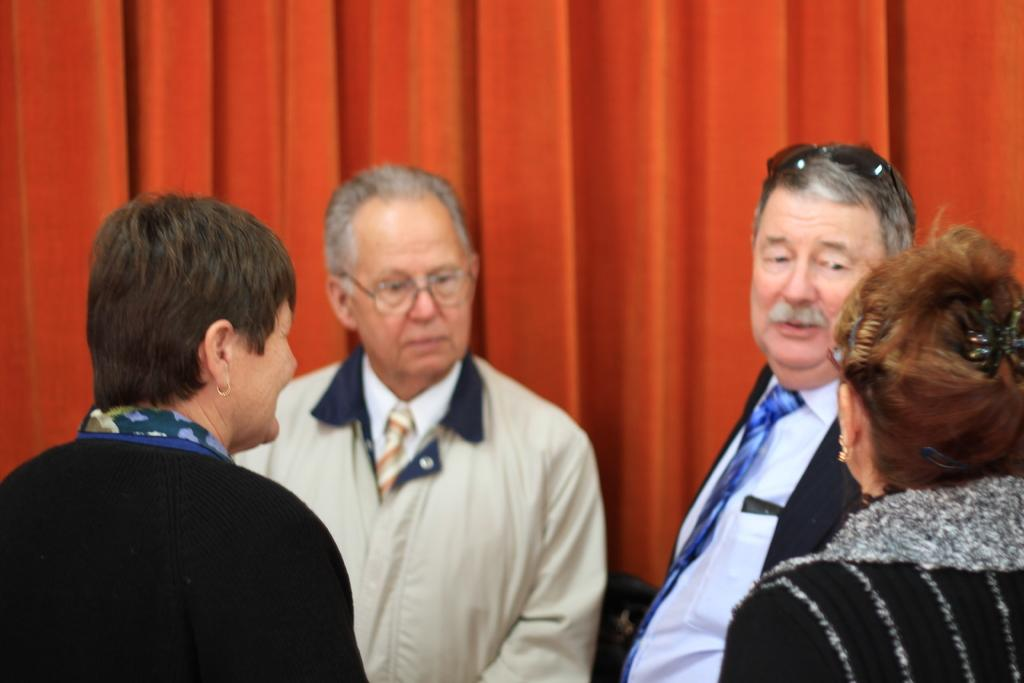How many people are in the image? There are persons in the image, but the exact number is not specified. What can be seen in the background of the image? There is a curtain in the background of the image. What type of lumber is being used by the fireman in the image? There is no fireman or lumber present in the image. Can you describe the root system of the plants in the image? There is no mention of plants or roots in the image, so it is not possible to describe their root system. 